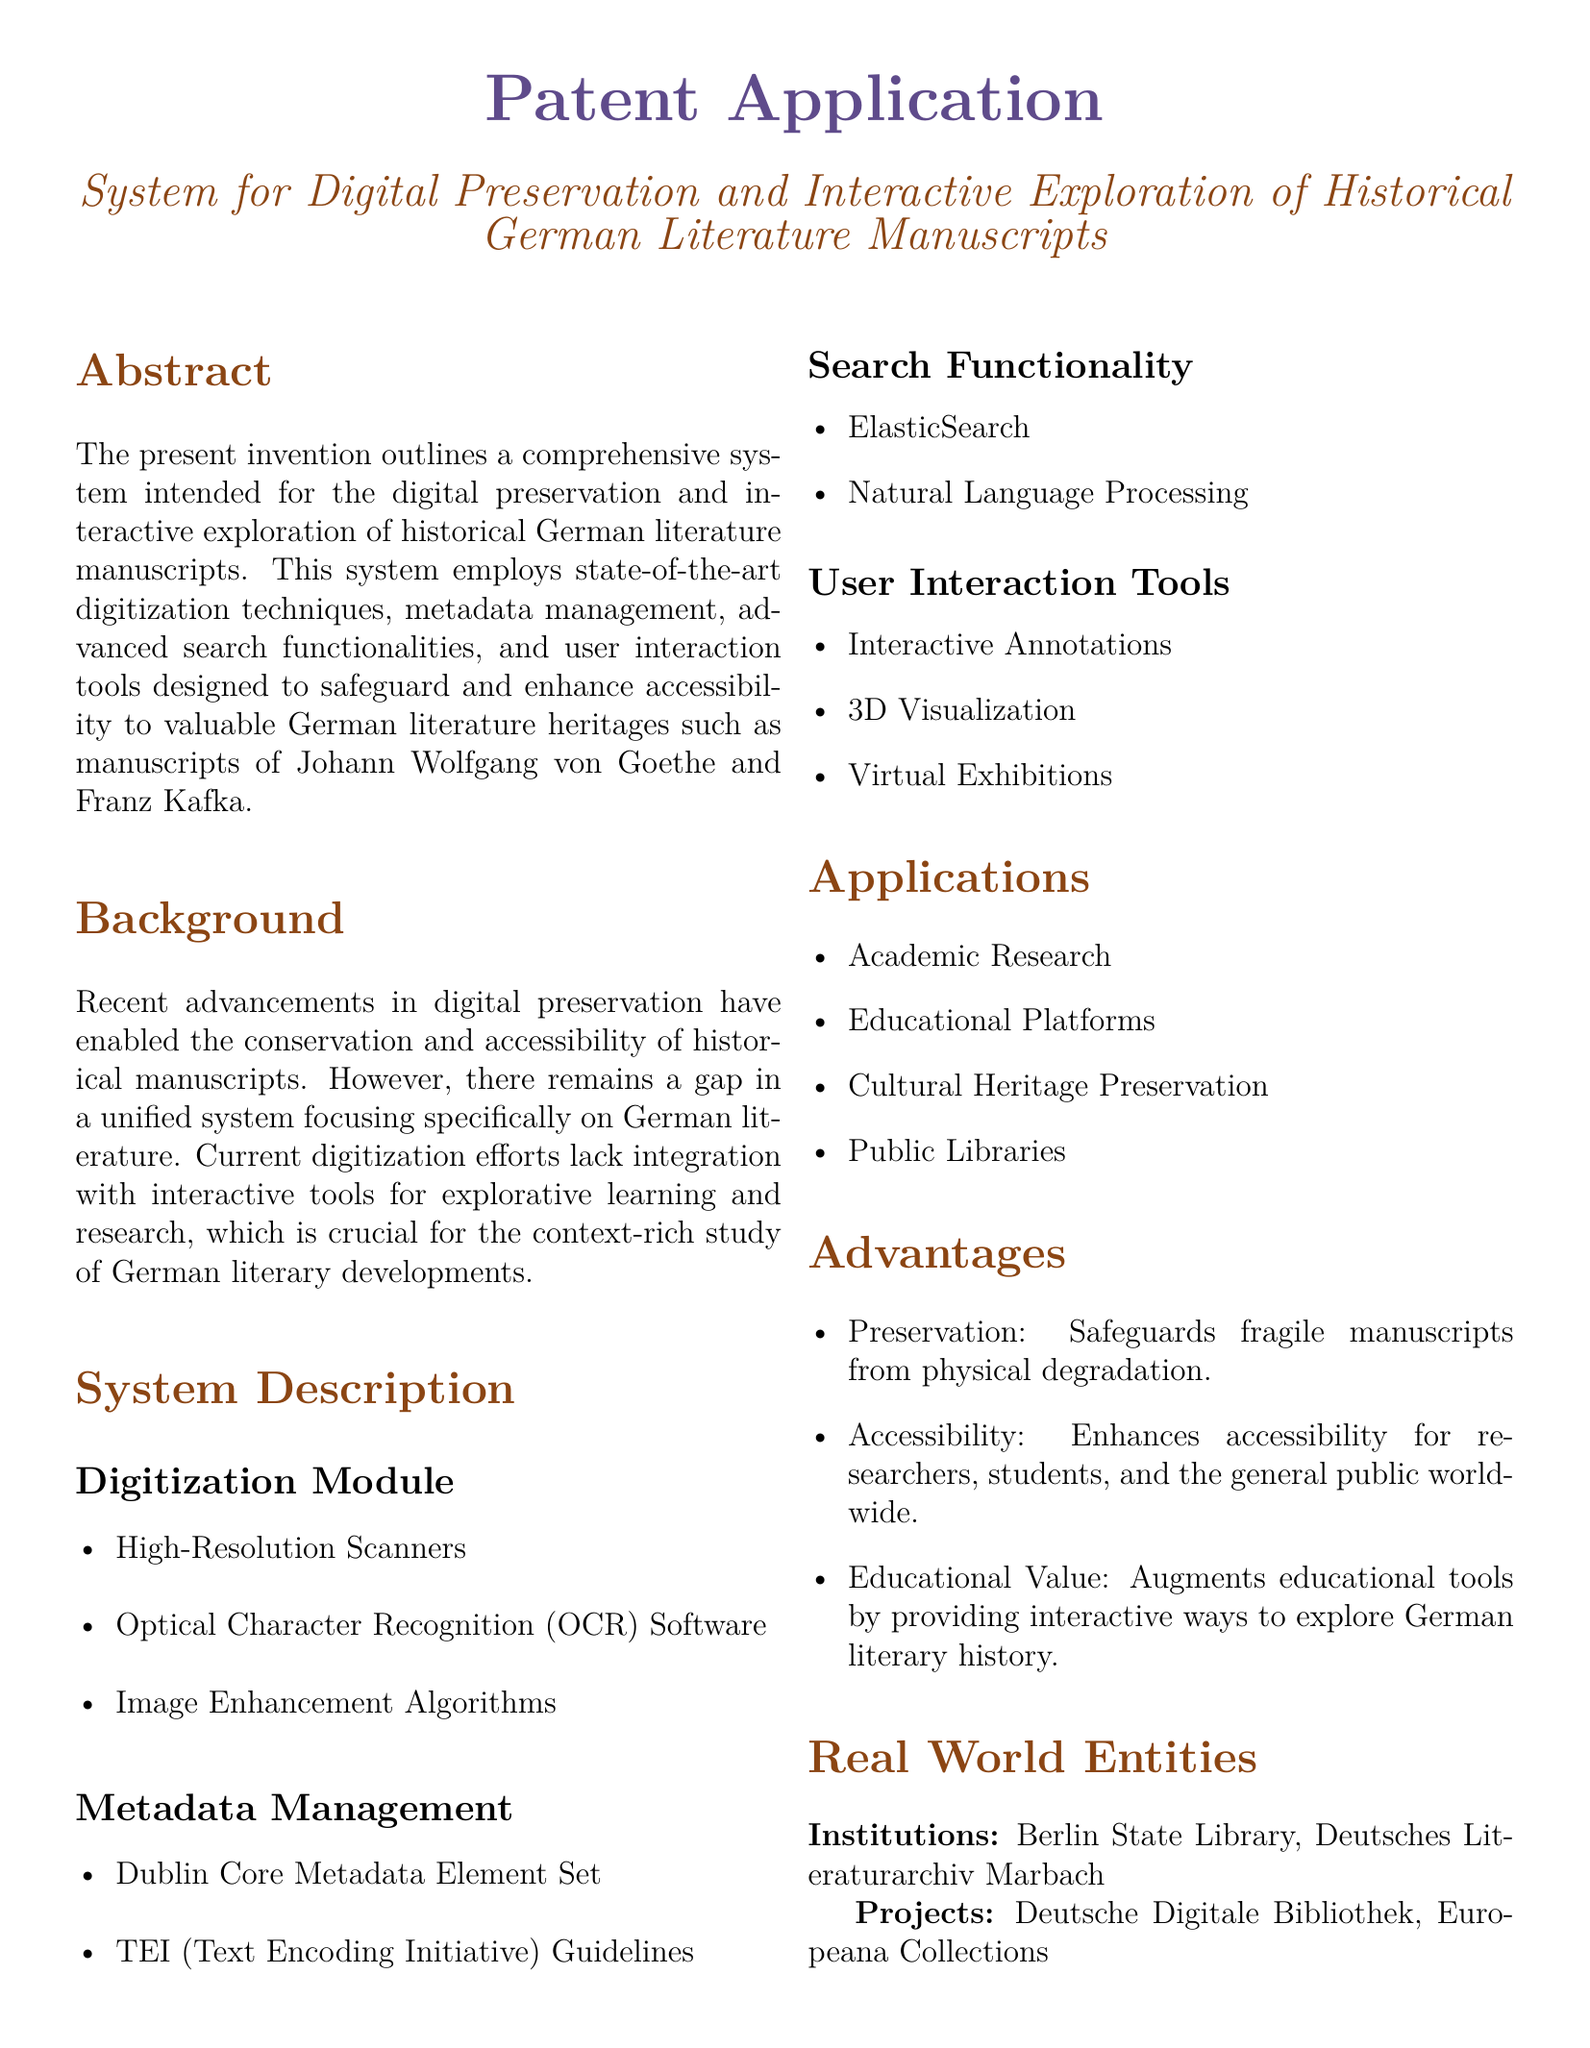What is the title of the patent application? The title is explicitly mentioned in the document under the system description as “System for Digital Preservation and Interactive Exploration of Historical German Literature Manuscripts.”
Answer: System for Digital Preservation and Interactive Exploration of Historical German Literature Manuscripts What is the main purpose of the system? The main purpose is highlighted in the abstract, which states that the system is intended for the digital preservation and interactive exploration of historical German literature manuscripts.
Answer: Digital preservation and interactive exploration of historical German literature manuscripts Which two authors are mentioned in the document? The background section specifies valuable German literature heritages, listing Johann Wolfgang von Goethe and Franz Kafka as key authors.
Answer: Johann Wolfgang von Goethe and Franz Kafka What type of algorithms are included in the digitization module? The digitization module lists several components, including image enhancement algorithms which are specifically mentioned.
Answer: Image enhancement algorithms What metadata standard is used in the system? The metadata management section describes the use of the Dublin Core Metadata Element Set as part of the metadata standards employed in the system.
Answer: Dublin Core Metadata Element Set Who are the mentioned institutions involved in the project? The real-world entities section of the document lists Berlin State Library and Deutsches Literaturarchiv Marbach as involved institutions.
Answer: Berlin State Library, Deutsches Literaturarchiv Marbach What is one advantage of the system related to accessibility? Within the advantages section, one explicit benefit stated is that it enhances accessibility for researchers, students, and the general public worldwide.
Answer: Enhances accessibility for researchers, students, and the general public worldwide In which areas can the system be applied? The applications section enumerates specific areas of application such as Academic Research, Educational Platforms, Cultural Heritage Preservation, and Public Libraries.
Answer: Academic Research, Educational Platforms, Cultural Heritage Preservation, Public Libraries What technology is utilized for search functionality in the system? The search functionality subsection mentions the use of ElasticSearch as one technology to facilitate search.
Answer: ElasticSearch 